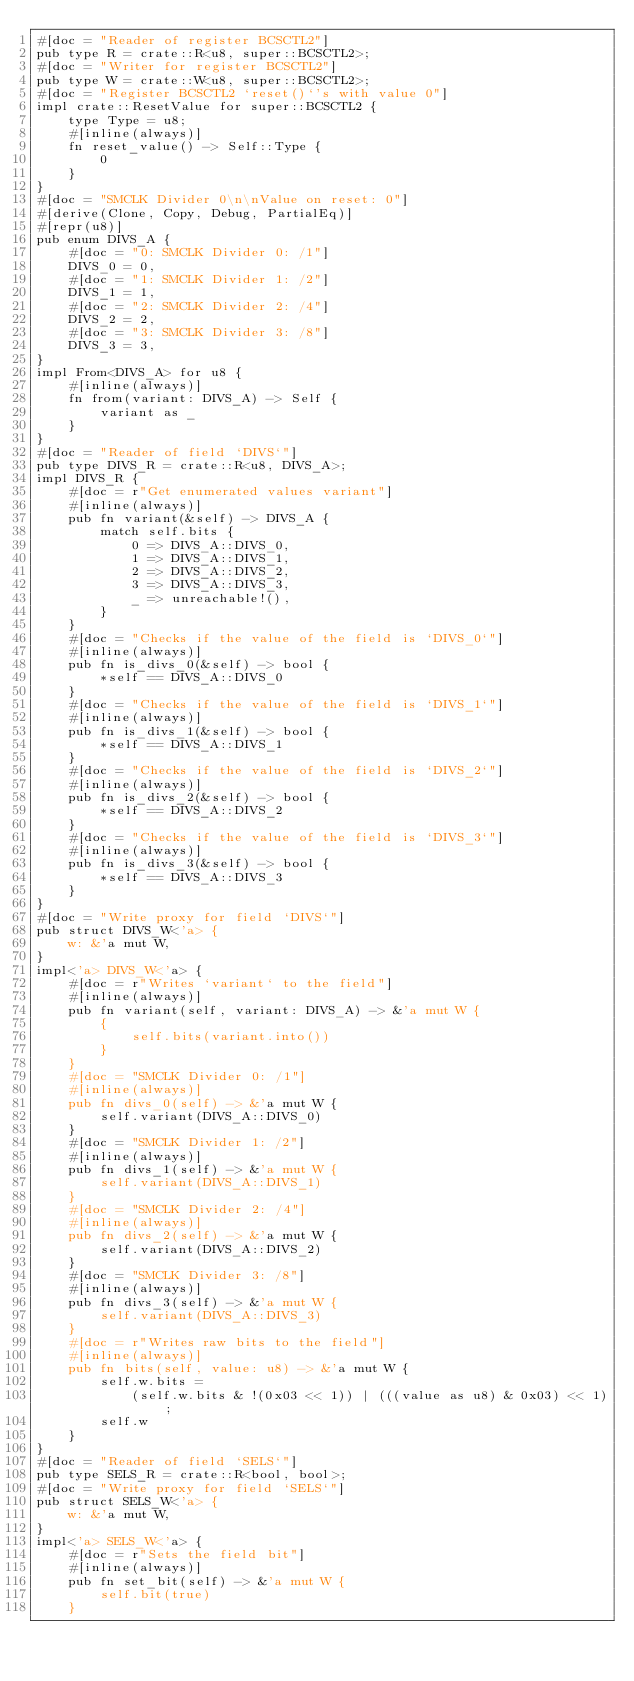<code> <loc_0><loc_0><loc_500><loc_500><_Rust_>#[doc = "Reader of register BCSCTL2"]
pub type R = crate::R<u8, super::BCSCTL2>;
#[doc = "Writer for register BCSCTL2"]
pub type W = crate::W<u8, super::BCSCTL2>;
#[doc = "Register BCSCTL2 `reset()`'s with value 0"]
impl crate::ResetValue for super::BCSCTL2 {
    type Type = u8;
    #[inline(always)]
    fn reset_value() -> Self::Type {
        0
    }
}
#[doc = "SMCLK Divider 0\n\nValue on reset: 0"]
#[derive(Clone, Copy, Debug, PartialEq)]
#[repr(u8)]
pub enum DIVS_A {
    #[doc = "0: SMCLK Divider 0: /1"]
    DIVS_0 = 0,
    #[doc = "1: SMCLK Divider 1: /2"]
    DIVS_1 = 1,
    #[doc = "2: SMCLK Divider 2: /4"]
    DIVS_2 = 2,
    #[doc = "3: SMCLK Divider 3: /8"]
    DIVS_3 = 3,
}
impl From<DIVS_A> for u8 {
    #[inline(always)]
    fn from(variant: DIVS_A) -> Self {
        variant as _
    }
}
#[doc = "Reader of field `DIVS`"]
pub type DIVS_R = crate::R<u8, DIVS_A>;
impl DIVS_R {
    #[doc = r"Get enumerated values variant"]
    #[inline(always)]
    pub fn variant(&self) -> DIVS_A {
        match self.bits {
            0 => DIVS_A::DIVS_0,
            1 => DIVS_A::DIVS_1,
            2 => DIVS_A::DIVS_2,
            3 => DIVS_A::DIVS_3,
            _ => unreachable!(),
        }
    }
    #[doc = "Checks if the value of the field is `DIVS_0`"]
    #[inline(always)]
    pub fn is_divs_0(&self) -> bool {
        *self == DIVS_A::DIVS_0
    }
    #[doc = "Checks if the value of the field is `DIVS_1`"]
    #[inline(always)]
    pub fn is_divs_1(&self) -> bool {
        *self == DIVS_A::DIVS_1
    }
    #[doc = "Checks if the value of the field is `DIVS_2`"]
    #[inline(always)]
    pub fn is_divs_2(&self) -> bool {
        *self == DIVS_A::DIVS_2
    }
    #[doc = "Checks if the value of the field is `DIVS_3`"]
    #[inline(always)]
    pub fn is_divs_3(&self) -> bool {
        *self == DIVS_A::DIVS_3
    }
}
#[doc = "Write proxy for field `DIVS`"]
pub struct DIVS_W<'a> {
    w: &'a mut W,
}
impl<'a> DIVS_W<'a> {
    #[doc = r"Writes `variant` to the field"]
    #[inline(always)]
    pub fn variant(self, variant: DIVS_A) -> &'a mut W {
        {
            self.bits(variant.into())
        }
    }
    #[doc = "SMCLK Divider 0: /1"]
    #[inline(always)]
    pub fn divs_0(self) -> &'a mut W {
        self.variant(DIVS_A::DIVS_0)
    }
    #[doc = "SMCLK Divider 1: /2"]
    #[inline(always)]
    pub fn divs_1(self) -> &'a mut W {
        self.variant(DIVS_A::DIVS_1)
    }
    #[doc = "SMCLK Divider 2: /4"]
    #[inline(always)]
    pub fn divs_2(self) -> &'a mut W {
        self.variant(DIVS_A::DIVS_2)
    }
    #[doc = "SMCLK Divider 3: /8"]
    #[inline(always)]
    pub fn divs_3(self) -> &'a mut W {
        self.variant(DIVS_A::DIVS_3)
    }
    #[doc = r"Writes raw bits to the field"]
    #[inline(always)]
    pub fn bits(self, value: u8) -> &'a mut W {
        self.w.bits =
            (self.w.bits & !(0x03 << 1)) | (((value as u8) & 0x03) << 1);
        self.w
    }
}
#[doc = "Reader of field `SELS`"]
pub type SELS_R = crate::R<bool, bool>;
#[doc = "Write proxy for field `SELS`"]
pub struct SELS_W<'a> {
    w: &'a mut W,
}
impl<'a> SELS_W<'a> {
    #[doc = r"Sets the field bit"]
    #[inline(always)]
    pub fn set_bit(self) -> &'a mut W {
        self.bit(true)
    }</code> 